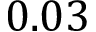<formula> <loc_0><loc_0><loc_500><loc_500>0 . 0 3</formula> 